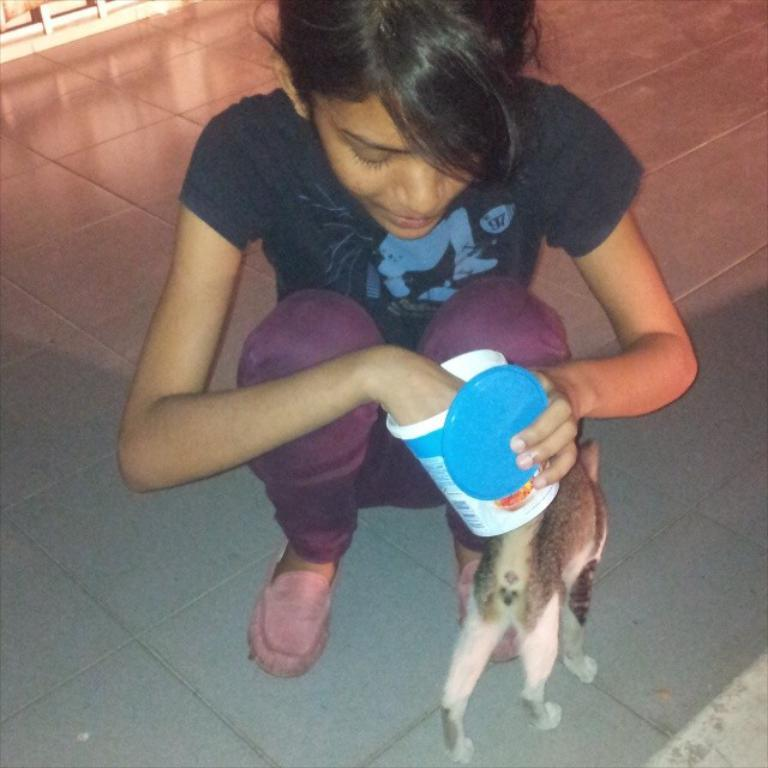Who is the main subject in the image? There is a girl in the image. What is the girl holding in her hand? The girl is holding a cup in her hand. Are there any animals present in the image? Yes, there is a cat beside the girl. What type of station is visible in the image? There is no station present in the image. What color is the mark on the girl's stocking? The girl is not wearing stockings in the image, so there is no mark to describe. 